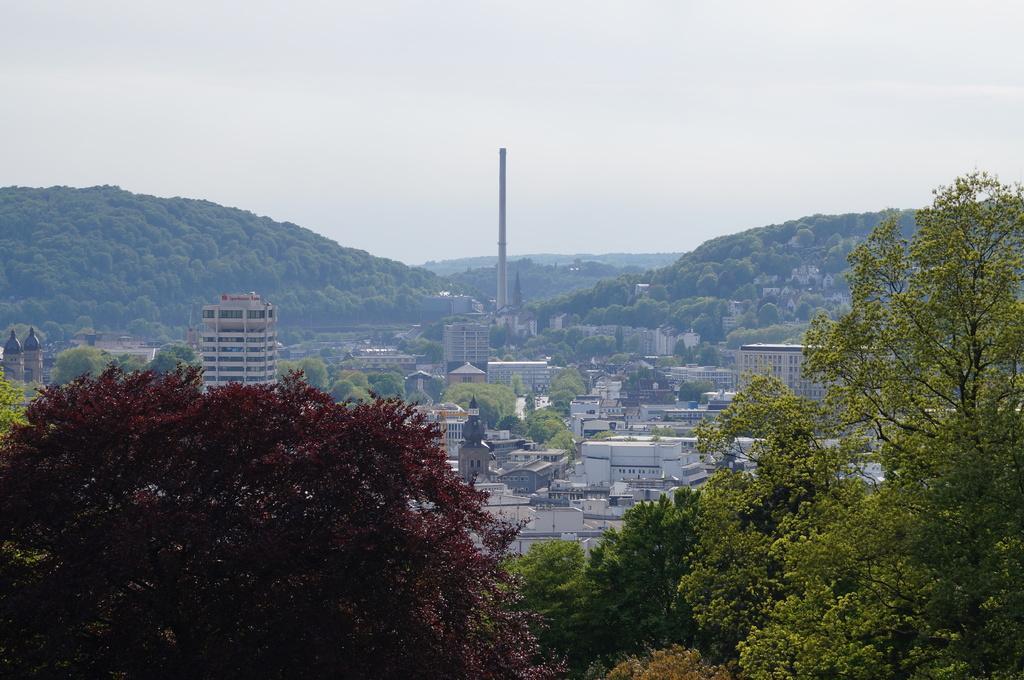How would you summarize this image in a sentence or two? In this picture we can see trees and in the background we can see buildings, mountains, sky. 